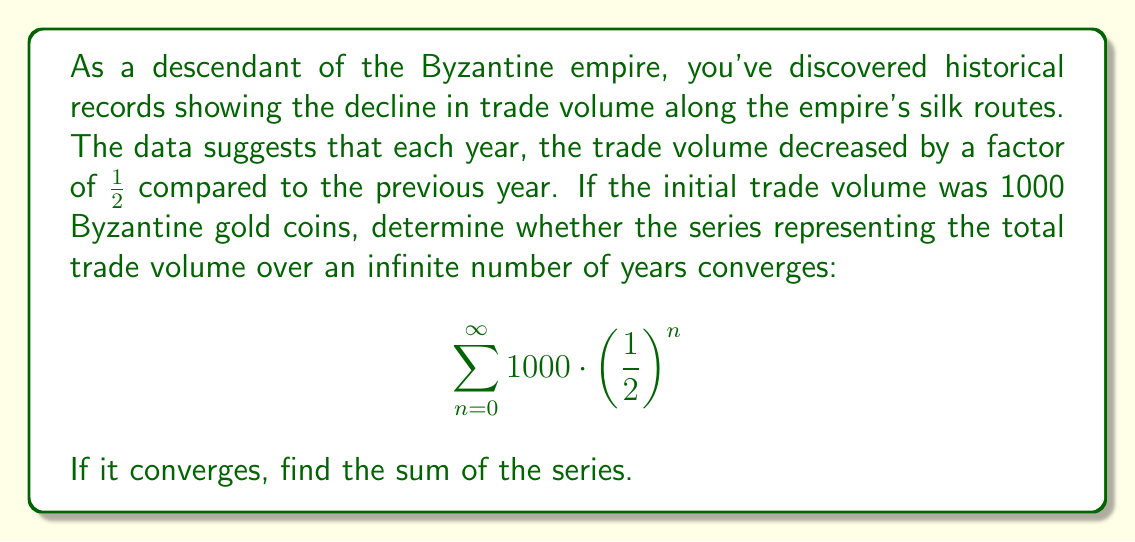Show me your answer to this math problem. Let's approach this step-by-step:

1) First, we need to recognize that this is a geometric series with:
   $a = 1000$ (first term)
   $r = \frac{1}{2}$ (common ratio)

2) For a geometric series $\sum_{n=0}^{\infty} ar^n$, it converges if $|r| < 1$

3) In our case, $|r| = |\frac{1}{2}| = \frac{1}{2} < 1$, so the series converges.

4) For a convergent geometric series, the sum is given by the formula:
   $$S_{\infty} = \frac{a}{1-r}$$

5) Substituting our values:
   $$S_{\infty} = \frac{1000}{1-\frac{1}{2}} = \frac{1000}{\frac{1}{2}} = 2000$$

This result represents the total trade volume over an infinite number of years, assuming the decline continues indefinitely. It's interesting to note that despite the trade continuing forever, the total volume is finite due to the rapid decline.
Answer: The series converges, and its sum is 2000 Byzantine gold coins. 